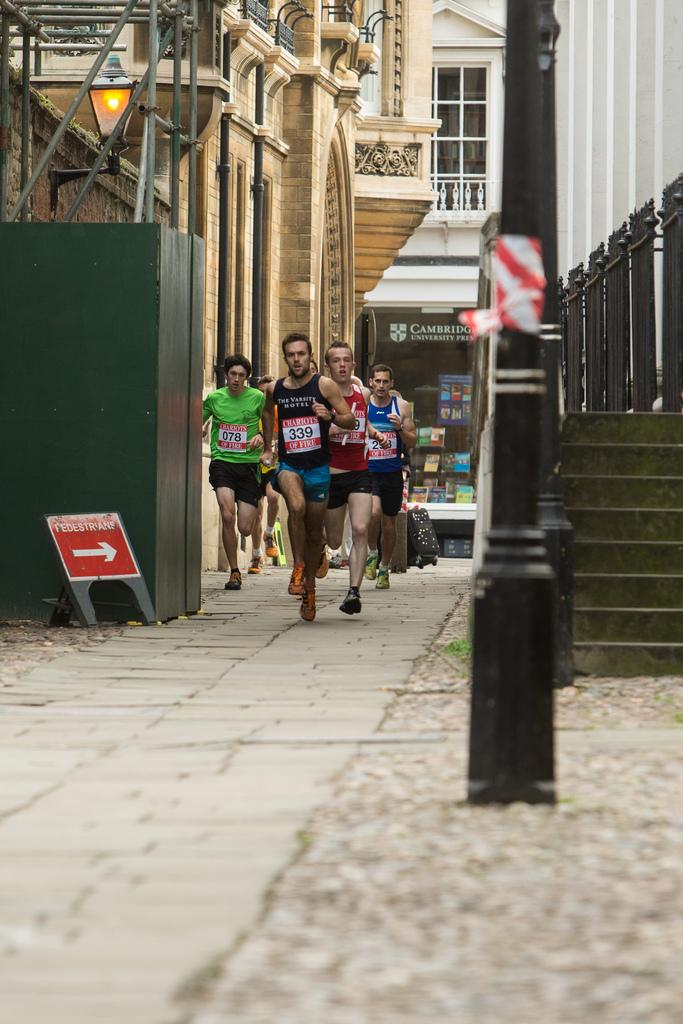What are the people in the image doing? The people in the image are running on the ground. What can be seen in the background of the image? There are buildings visible in the image. What might help people navigate in the image? A direction board is present in the image. What architectural feature is present in the image? There is a staircase in the image. What might provide illumination in the image? There is a light in the image. What type of signage is visible in the image? Posters are visible in the image. Can you describe any unspecified objects in the image? There are some unspecified objects in the image, but their purpose or appearance cannot be determined from the provided facts. What is the tendency of the trouble in the image? There is no trouble present in the image, so it is not possible to determine any tendencies. 